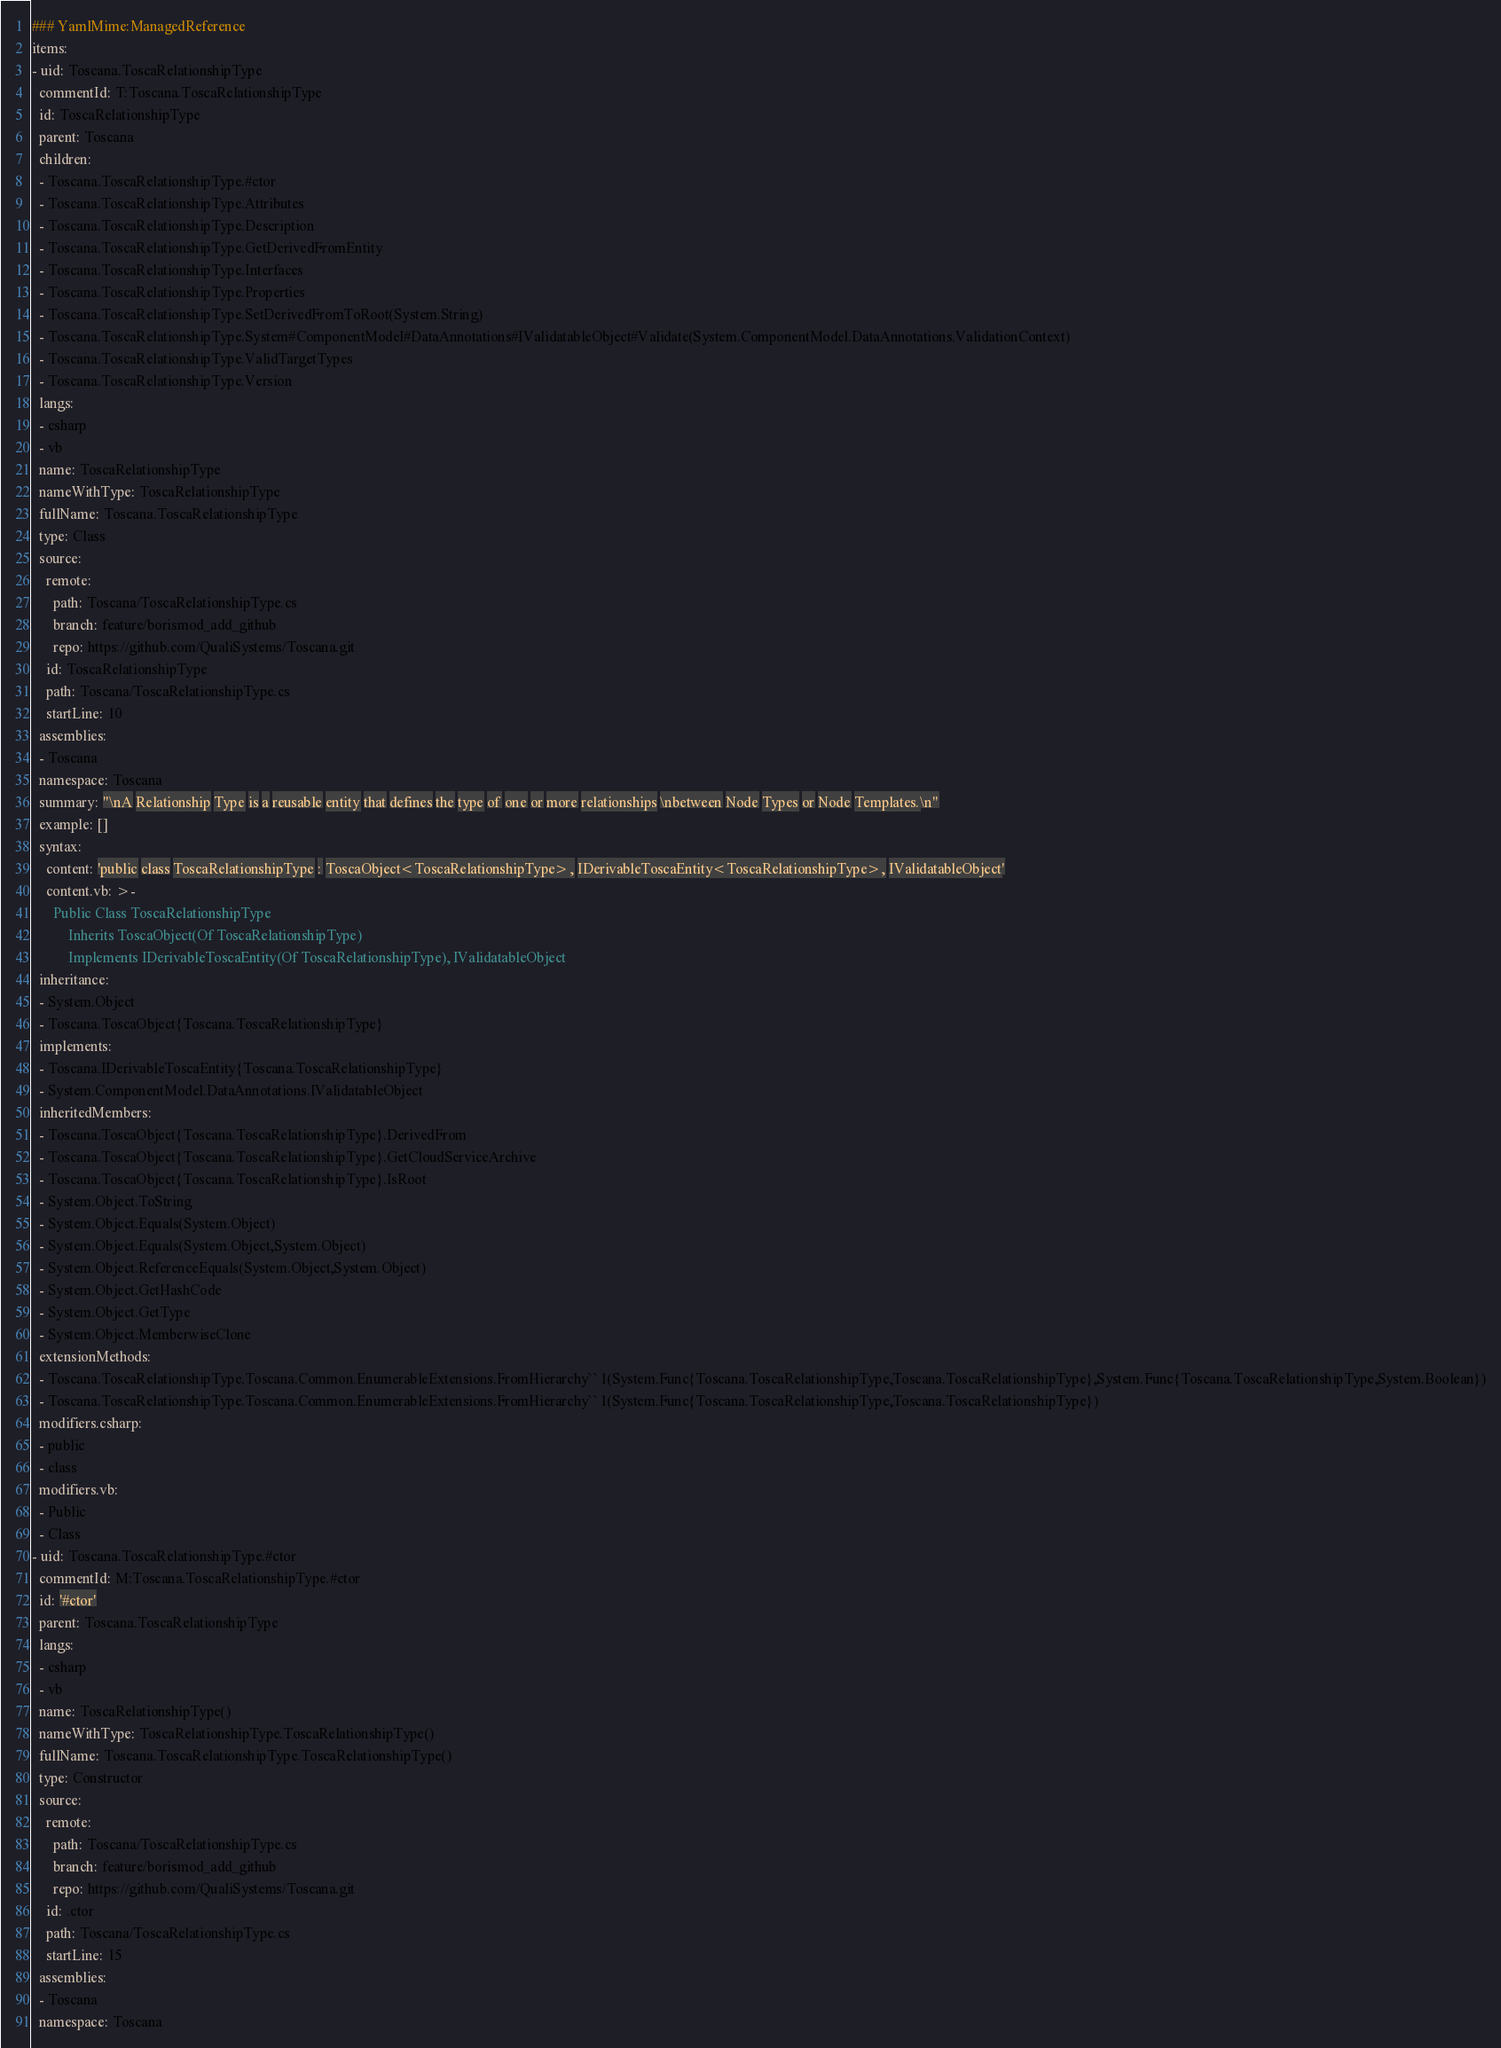<code> <loc_0><loc_0><loc_500><loc_500><_YAML_>### YamlMime:ManagedReference
items:
- uid: Toscana.ToscaRelationshipType
  commentId: T:Toscana.ToscaRelationshipType
  id: ToscaRelationshipType
  parent: Toscana
  children:
  - Toscana.ToscaRelationshipType.#ctor
  - Toscana.ToscaRelationshipType.Attributes
  - Toscana.ToscaRelationshipType.Description
  - Toscana.ToscaRelationshipType.GetDerivedFromEntity
  - Toscana.ToscaRelationshipType.Interfaces
  - Toscana.ToscaRelationshipType.Properties
  - Toscana.ToscaRelationshipType.SetDerivedFromToRoot(System.String)
  - Toscana.ToscaRelationshipType.System#ComponentModel#DataAnnotations#IValidatableObject#Validate(System.ComponentModel.DataAnnotations.ValidationContext)
  - Toscana.ToscaRelationshipType.ValidTargetTypes
  - Toscana.ToscaRelationshipType.Version
  langs:
  - csharp
  - vb
  name: ToscaRelationshipType
  nameWithType: ToscaRelationshipType
  fullName: Toscana.ToscaRelationshipType
  type: Class
  source:
    remote:
      path: Toscana/ToscaRelationshipType.cs
      branch: feature/borismod_add_github
      repo: https://github.com/QualiSystems/Toscana.git
    id: ToscaRelationshipType
    path: Toscana/ToscaRelationshipType.cs
    startLine: 10
  assemblies:
  - Toscana
  namespace: Toscana
  summary: "\nA Relationship Type is a reusable entity that defines the type of one or more relationships \nbetween Node Types or Node Templates.\n"
  example: []
  syntax:
    content: 'public class ToscaRelationshipType : ToscaObject<ToscaRelationshipType>, IDerivableToscaEntity<ToscaRelationshipType>, IValidatableObject'
    content.vb: >-
      Public Class ToscaRelationshipType
          Inherits ToscaObject(Of ToscaRelationshipType)
          Implements IDerivableToscaEntity(Of ToscaRelationshipType), IValidatableObject
  inheritance:
  - System.Object
  - Toscana.ToscaObject{Toscana.ToscaRelationshipType}
  implements:
  - Toscana.IDerivableToscaEntity{Toscana.ToscaRelationshipType}
  - System.ComponentModel.DataAnnotations.IValidatableObject
  inheritedMembers:
  - Toscana.ToscaObject{Toscana.ToscaRelationshipType}.DerivedFrom
  - Toscana.ToscaObject{Toscana.ToscaRelationshipType}.GetCloudServiceArchive
  - Toscana.ToscaObject{Toscana.ToscaRelationshipType}.IsRoot
  - System.Object.ToString
  - System.Object.Equals(System.Object)
  - System.Object.Equals(System.Object,System.Object)
  - System.Object.ReferenceEquals(System.Object,System.Object)
  - System.Object.GetHashCode
  - System.Object.GetType
  - System.Object.MemberwiseClone
  extensionMethods:
  - Toscana.ToscaRelationshipType.Toscana.Common.EnumerableExtensions.FromHierarchy``1(System.Func{Toscana.ToscaRelationshipType,Toscana.ToscaRelationshipType},System.Func{Toscana.ToscaRelationshipType,System.Boolean})
  - Toscana.ToscaRelationshipType.Toscana.Common.EnumerableExtensions.FromHierarchy``1(System.Func{Toscana.ToscaRelationshipType,Toscana.ToscaRelationshipType})
  modifiers.csharp:
  - public
  - class
  modifiers.vb:
  - Public
  - Class
- uid: Toscana.ToscaRelationshipType.#ctor
  commentId: M:Toscana.ToscaRelationshipType.#ctor
  id: '#ctor'
  parent: Toscana.ToscaRelationshipType
  langs:
  - csharp
  - vb
  name: ToscaRelationshipType()
  nameWithType: ToscaRelationshipType.ToscaRelationshipType()
  fullName: Toscana.ToscaRelationshipType.ToscaRelationshipType()
  type: Constructor
  source:
    remote:
      path: Toscana/ToscaRelationshipType.cs
      branch: feature/borismod_add_github
      repo: https://github.com/QualiSystems/Toscana.git
    id: .ctor
    path: Toscana/ToscaRelationshipType.cs
    startLine: 15
  assemblies:
  - Toscana
  namespace: Toscana</code> 